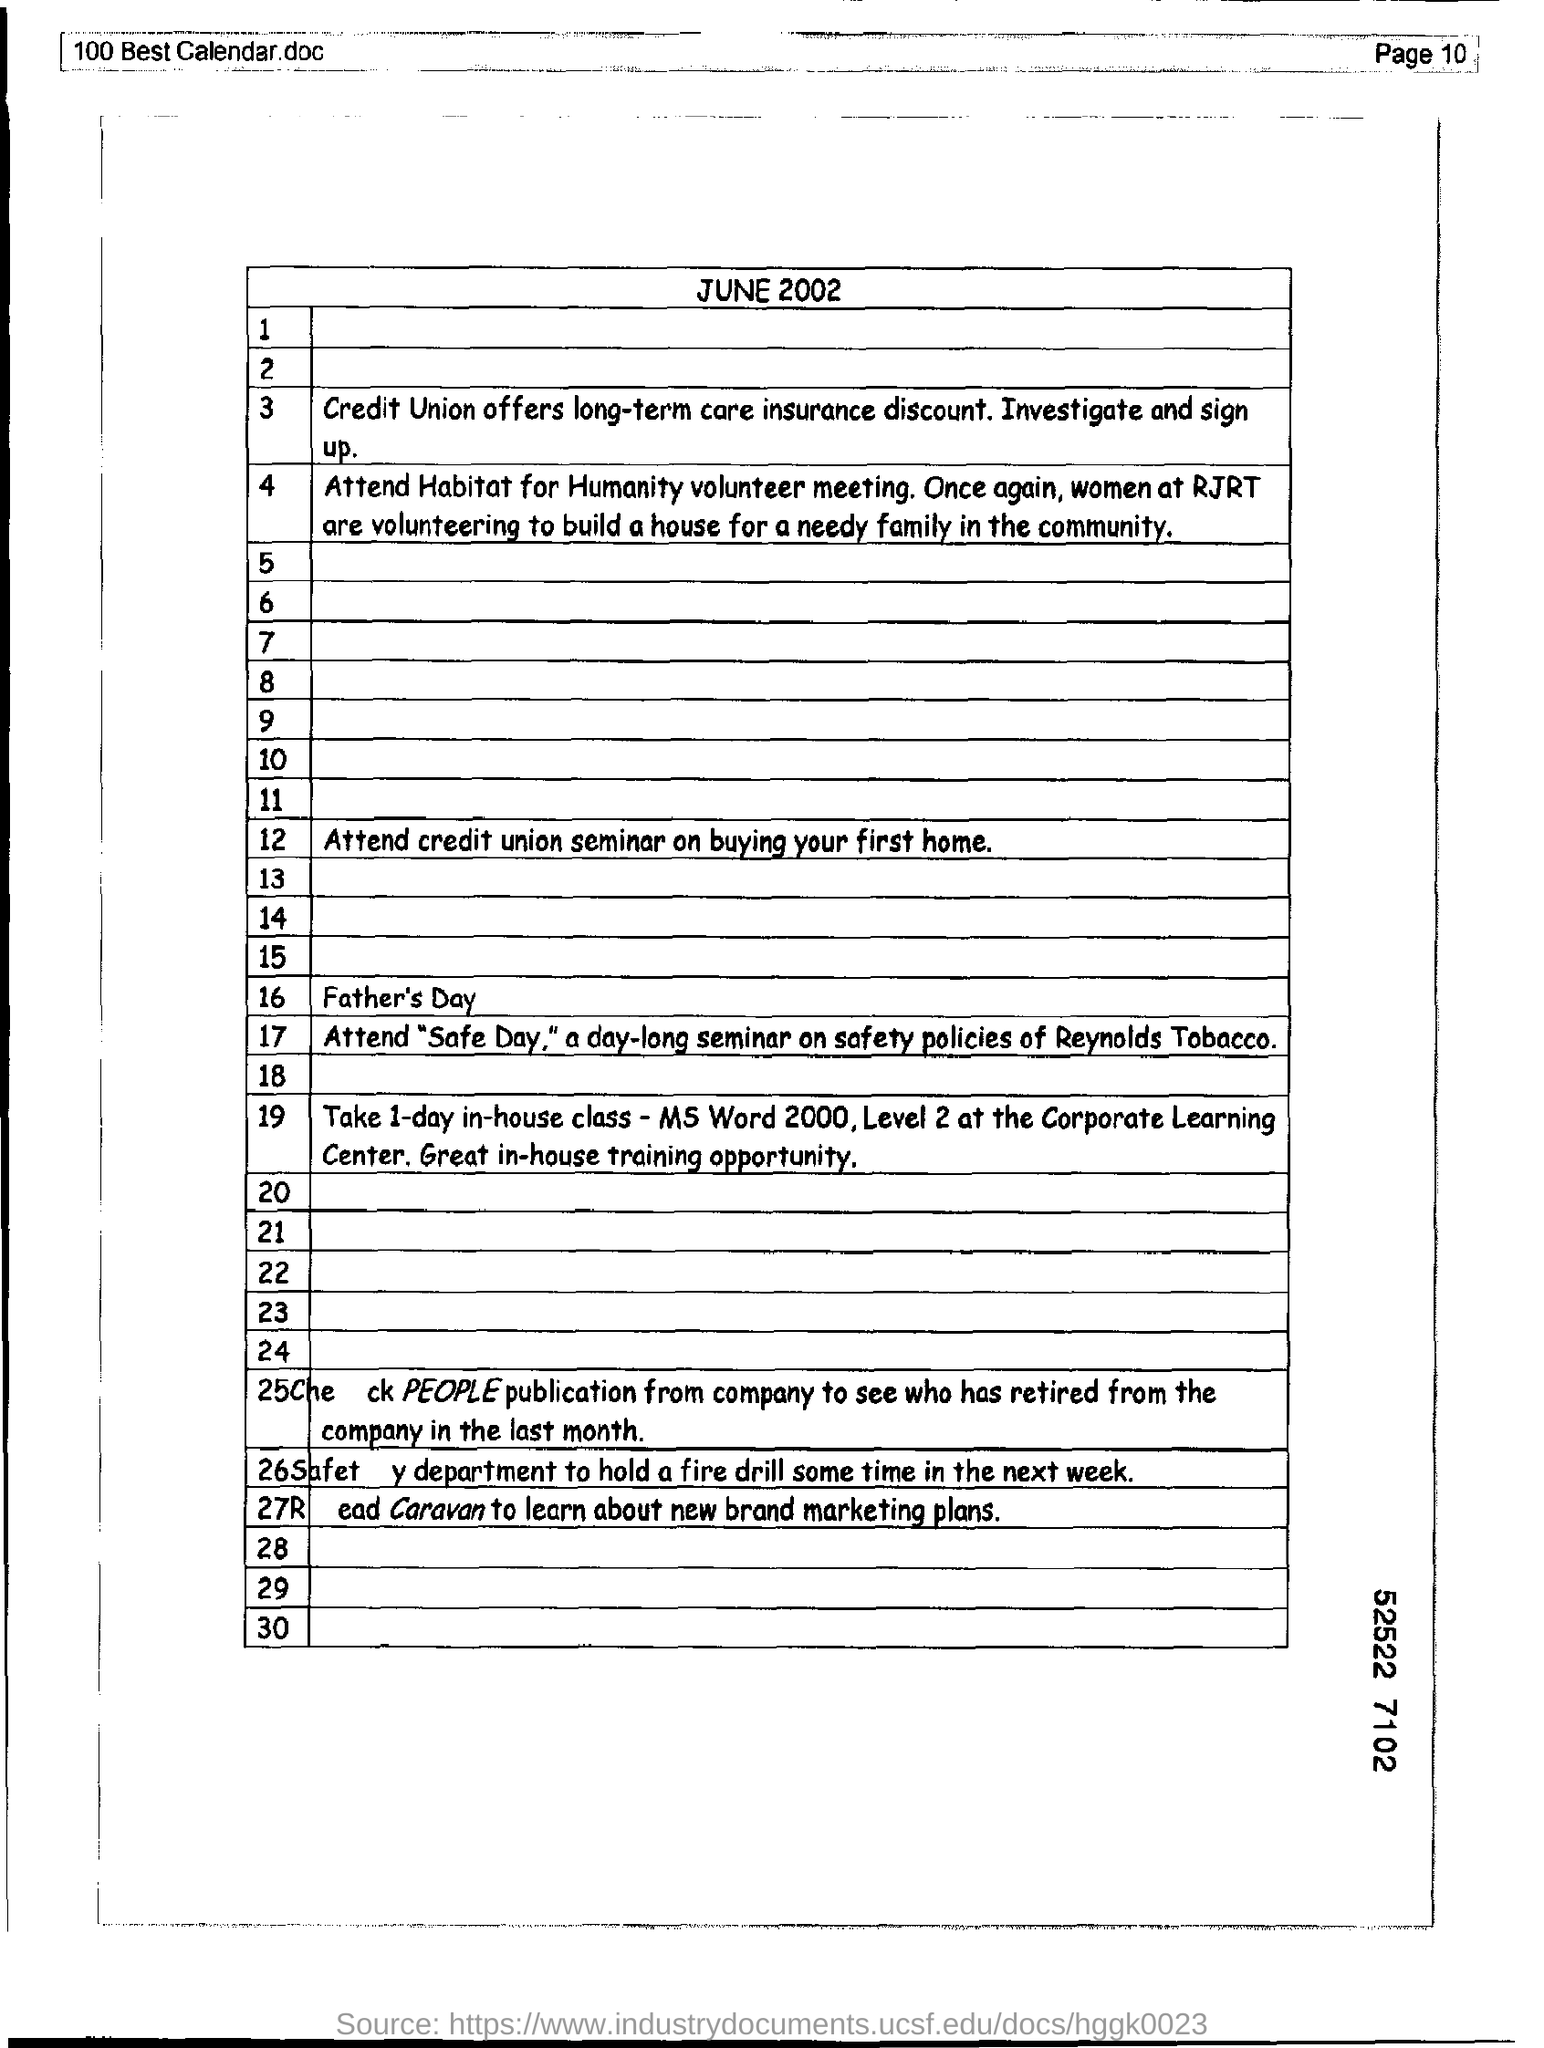What is the date mention in this document?
Provide a succinct answer. June 2002. What is credit union offers ?
Keep it short and to the point. Long-term care insurance discount. 